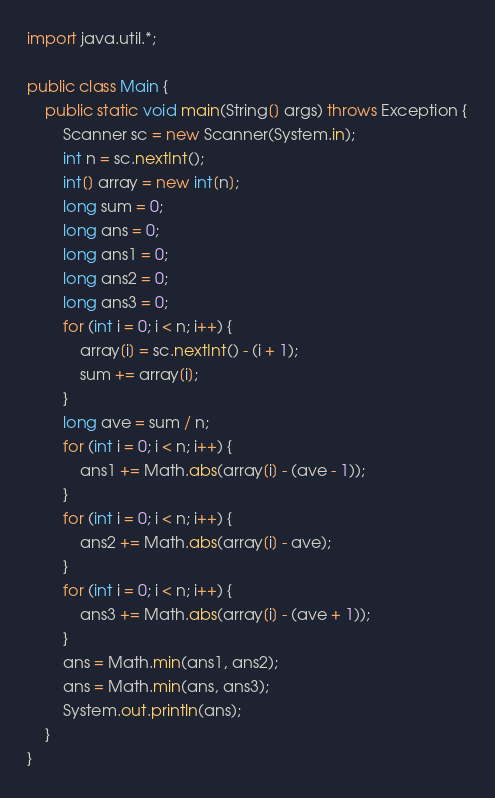Convert code to text. <code><loc_0><loc_0><loc_500><loc_500><_Java_>import java.util.*;
 
public class Main {
    public static void main(String[] args) throws Exception {
        Scanner sc = new Scanner(System.in);
        int n = sc.nextInt();
        int[] array = new int[n];
        long sum = 0;
        long ans = 0;
        long ans1 = 0;
        long ans2 = 0;
        long ans3 = 0;
        for (int i = 0; i < n; i++) {
            array[i] = sc.nextInt() - (i + 1);
            sum += array[i];
        }
        long ave = sum / n;
        for (int i = 0; i < n; i++) {
            ans1 += Math.abs(array[i] - (ave - 1));
        }
        for (int i = 0; i < n; i++) {
            ans2 += Math.abs(array[i] - ave);
        }
        for (int i = 0; i < n; i++) {
            ans3 += Math.abs(array[i] - (ave + 1));
        }
        ans = Math.min(ans1, ans2);
        ans = Math.min(ans, ans3);
        System.out.println(ans);
    }    
}
</code> 